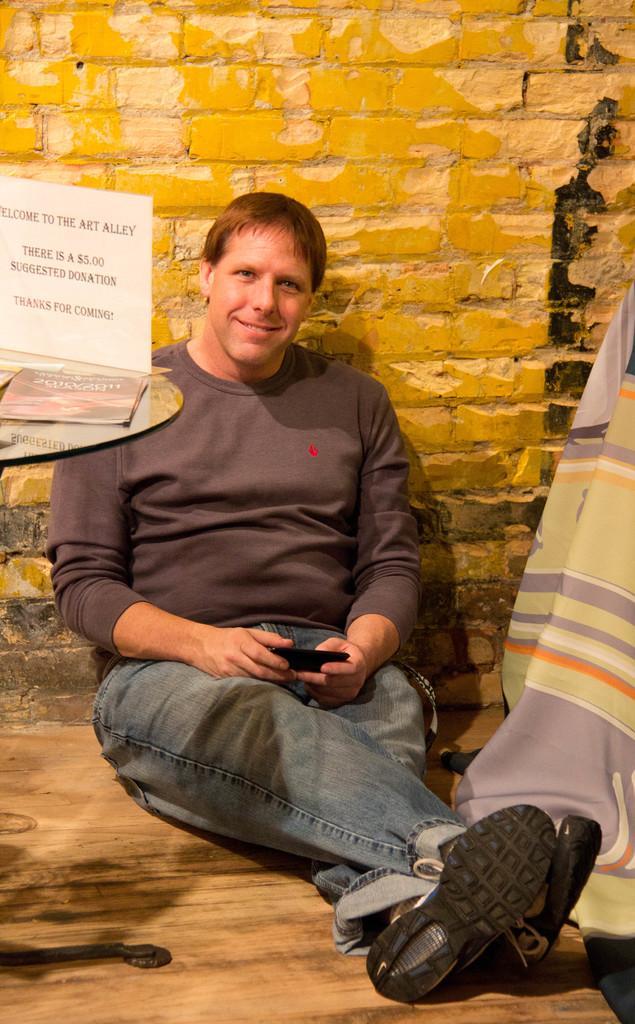Could you give a brief overview of what you see in this image? In this image in the center there is one man who is holding a phone, and at the bottom there is walkway and on the right side of the image there is a blanket. And on the left side of the image there is a table, book and board. In the background there is wall. 